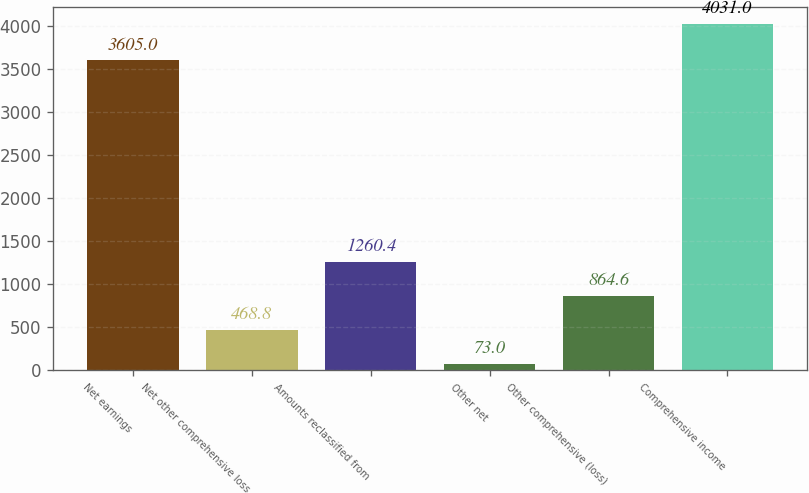Convert chart. <chart><loc_0><loc_0><loc_500><loc_500><bar_chart><fcel>Net earnings<fcel>Net other comprehensive loss<fcel>Amounts reclassified from<fcel>Other net<fcel>Other comprehensive (loss)<fcel>Comprehensive income<nl><fcel>3605<fcel>468.8<fcel>1260.4<fcel>73<fcel>864.6<fcel>4031<nl></chart> 